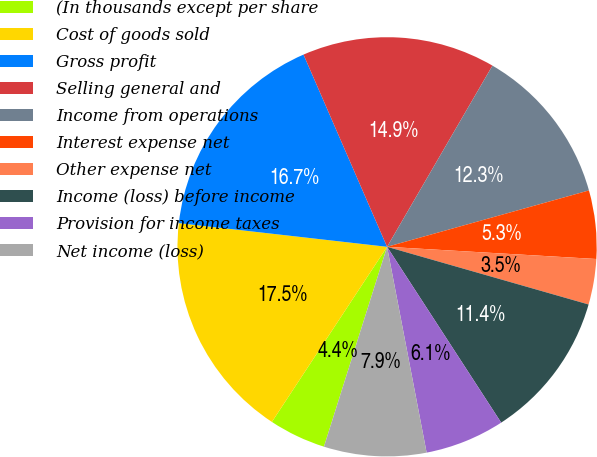<chart> <loc_0><loc_0><loc_500><loc_500><pie_chart><fcel>(In thousands except per share<fcel>Cost of goods sold<fcel>Gross profit<fcel>Selling general and<fcel>Income from operations<fcel>Interest expense net<fcel>Other expense net<fcel>Income (loss) before income<fcel>Provision for income taxes<fcel>Net income (loss)<nl><fcel>4.39%<fcel>17.54%<fcel>16.67%<fcel>14.91%<fcel>12.28%<fcel>5.26%<fcel>3.51%<fcel>11.4%<fcel>6.14%<fcel>7.89%<nl></chart> 